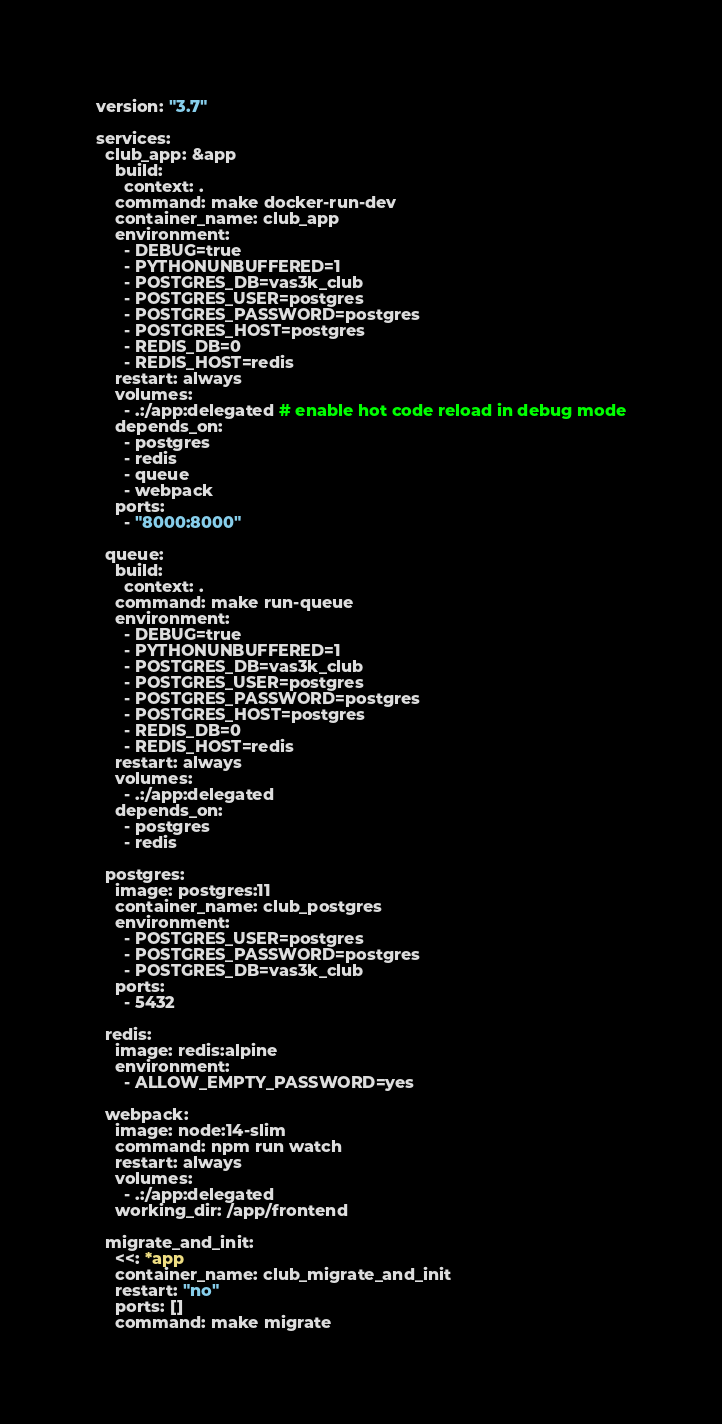Convert code to text. <code><loc_0><loc_0><loc_500><loc_500><_YAML_>version: "3.7"

services:
  club_app: &app
    build:
      context: .
    command: make docker-run-dev
    container_name: club_app
    environment:
      - DEBUG=true
      - PYTHONUNBUFFERED=1
      - POSTGRES_DB=vas3k_club
      - POSTGRES_USER=postgres
      - POSTGRES_PASSWORD=postgres
      - POSTGRES_HOST=postgres
      - REDIS_DB=0
      - REDIS_HOST=redis
    restart: always
    volumes:
      - .:/app:delegated # enable hot code reload in debug mode
    depends_on:
      - postgres
      - redis
      - queue
      - webpack
    ports:
      - "8000:8000"

  queue:
    build:
      context: .
    command: make run-queue
    environment:
      - DEBUG=true
      - PYTHONUNBUFFERED=1
      - POSTGRES_DB=vas3k_club
      - POSTGRES_USER=postgres
      - POSTGRES_PASSWORD=postgres
      - POSTGRES_HOST=postgres
      - REDIS_DB=0
      - REDIS_HOST=redis
    restart: always
    volumes:
      - .:/app:delegated
    depends_on:
      - postgres
      - redis

  postgres:
    image: postgres:11
    container_name: club_postgres
    environment:
      - POSTGRES_USER=postgres
      - POSTGRES_PASSWORD=postgres
      - POSTGRES_DB=vas3k_club
    ports:
      - 5432

  redis:
    image: redis:alpine
    environment:
      - ALLOW_EMPTY_PASSWORD=yes

  webpack:
    image: node:14-slim
    command: npm run watch
    restart: always
    volumes:
      - .:/app:delegated
    working_dir: /app/frontend

  migrate_and_init:
    <<: *app
    container_name: club_migrate_and_init
    restart: "no"
    ports: []
    command: make migrate
</code> 